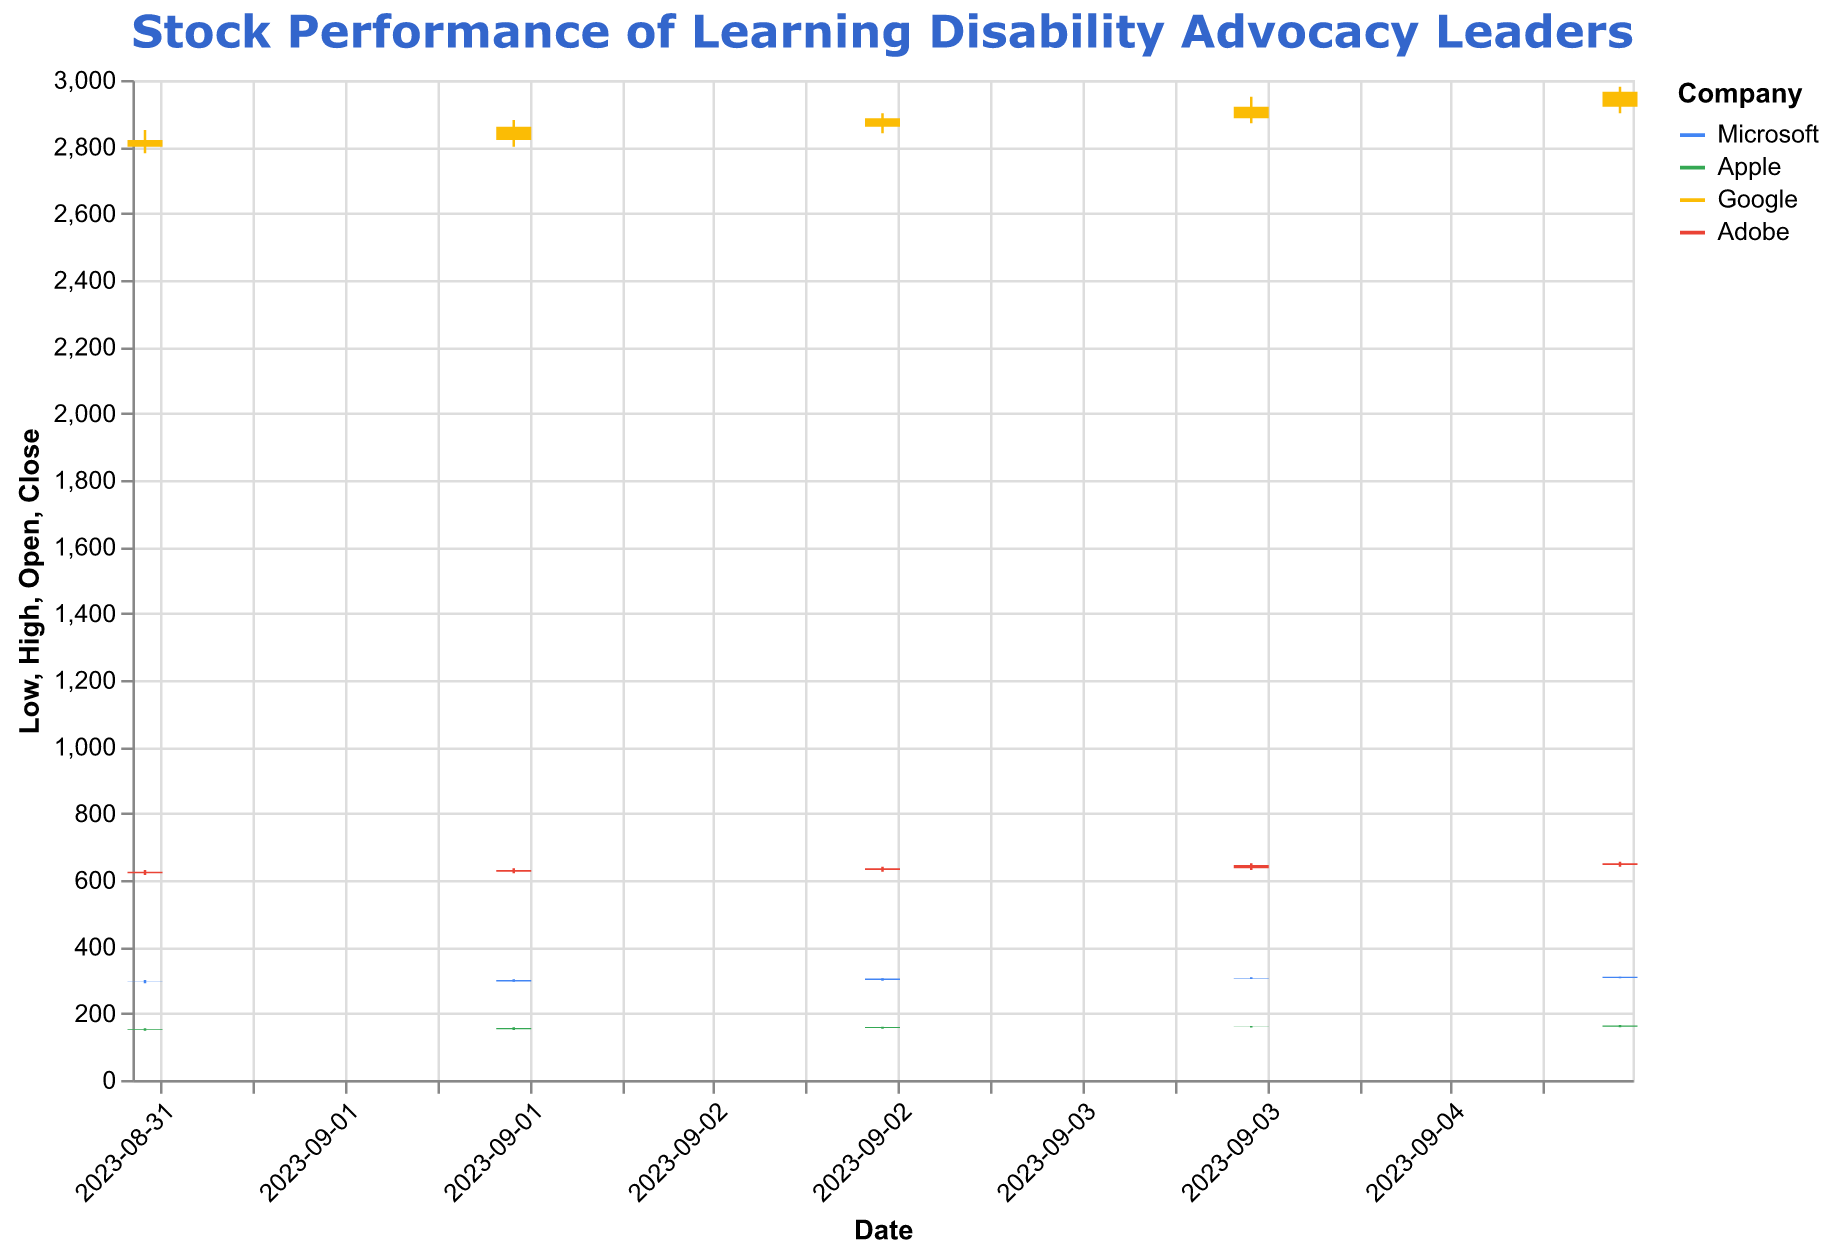What is the highest stock price of Google on September 5, 2023? On the figure, find the candlestick for Google on September 5, 2023, and identify the highest point on the candle, which represents the highest stock price.
Answer: 2980.00 Which company had the lowest opening price on September 1, 2023? Look at the candlesticks for all companies on September 1, 2023, and compare the opening prices (the bottom of the bar if it’s upward, or the top of the bar if it’s downward).
Answer: Apple Between Microsoft and Apple, which company had a higher closing price on September 3, 2023? Find the candlesticks for Microsoft and Apple on September 3, 2023, and compare the closing prices (the top of the bar if upward, or the bottom of the bar if downward).
Answer: Microsoft What was the average closing price of Adobe from September 1 to September 5, 2023? Extract the closing prices of Adobe from September 1 to September 5, which are [625, 630, 635, 645, 650]. Sum these values (625 + 630 + 635 + 645 + 650 = 3185) and then divide by 5 to get the average.
Answer: 637.00 Which company has the highest volume of trades on September 4, 2023? Check the volume of trades for all companies on September 4, 2023, and identify the highest one.
Answer: Apple How many companies had a higher closing price on September 5, 2023, than on September 4, 2023? Compare the closing prices on September 4 and September 5 for each company and count those with higher prices on September 5. Microsoft, Apple, Google, and Adobe all have higher closing prices on September 5, 2023.
Answer: 4 What is the difference between the highest and lowest prices of Apple on September 5, 2023? Look at Apple's candlestick on September 5, 2023, and subtract the lowest price from the highest price (165.00 - 158.50).
Answer: 6.50 Which company showed the most significant increase in closing price from September 1 to September 5, 2023? Calculate the difference in closing prices from September 1 to September 5 for each company, then identify the largest increase: Microsoft (309.50 - 295.50 = 14), Apple (163.50 - 152.50 = 11), Google (2965.00 - 2820.00 = 145), Adobe (650 - 625 = 25).
Answer: Google 